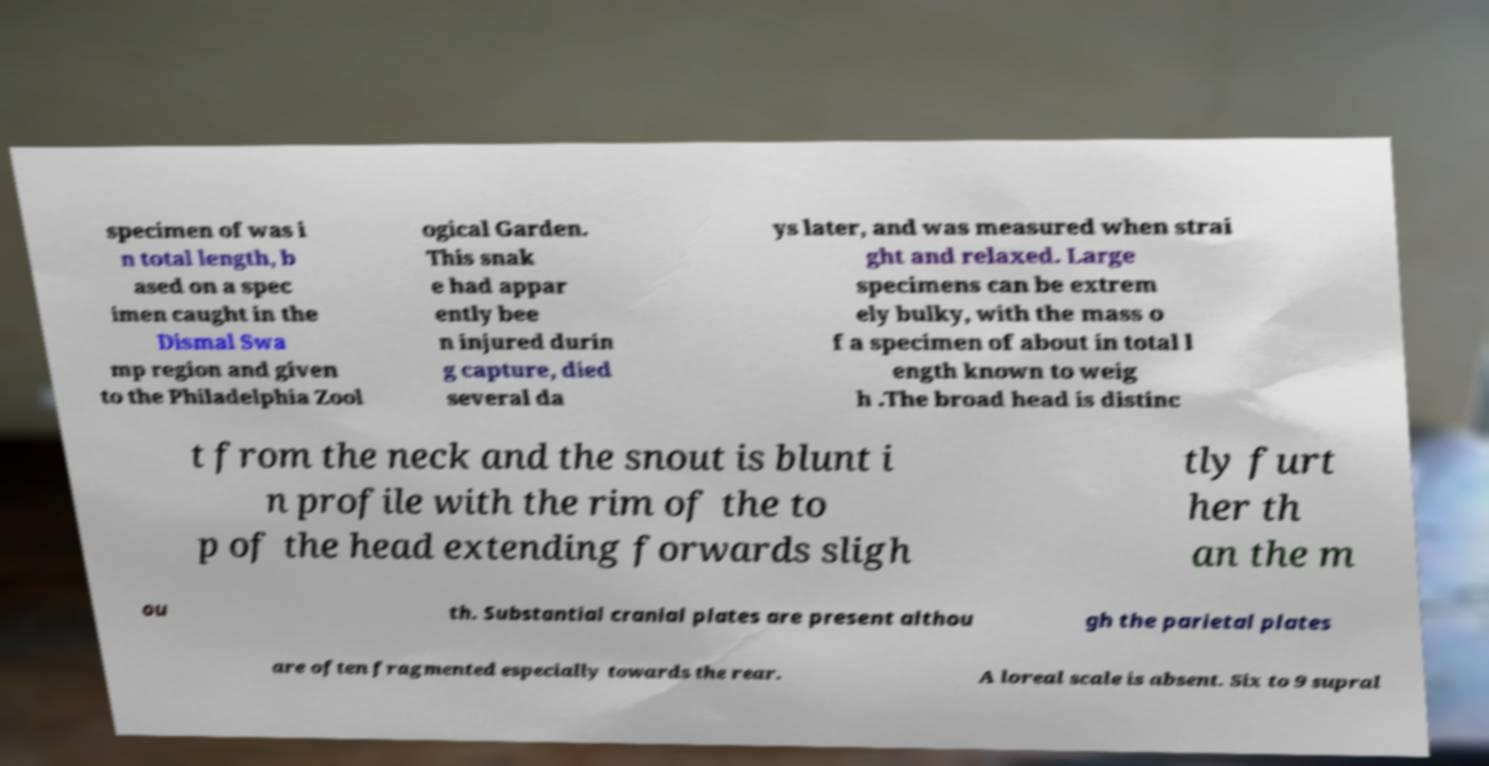Please identify and transcribe the text found in this image. specimen of was i n total length, b ased on a spec imen caught in the Dismal Swa mp region and given to the Philadelphia Zool ogical Garden. This snak e had appar ently bee n injured durin g capture, died several da ys later, and was measured when strai ght and relaxed. Large specimens can be extrem ely bulky, with the mass o f a specimen of about in total l ength known to weig h .The broad head is distinc t from the neck and the snout is blunt i n profile with the rim of the to p of the head extending forwards sligh tly furt her th an the m ou th. Substantial cranial plates are present althou gh the parietal plates are often fragmented especially towards the rear. A loreal scale is absent. Six to 9 supral 